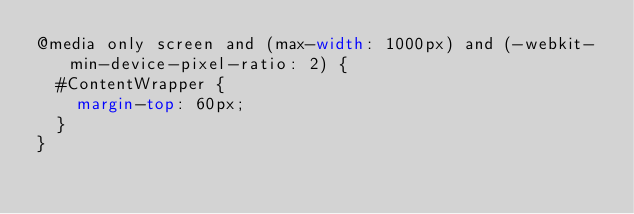<code> <loc_0><loc_0><loc_500><loc_500><_CSS_>@media only screen and (max-width: 1000px) and (-webkit-min-device-pixel-ratio: 2) {
  #ContentWrapper {
    margin-top: 60px;
  }
}
</code> 